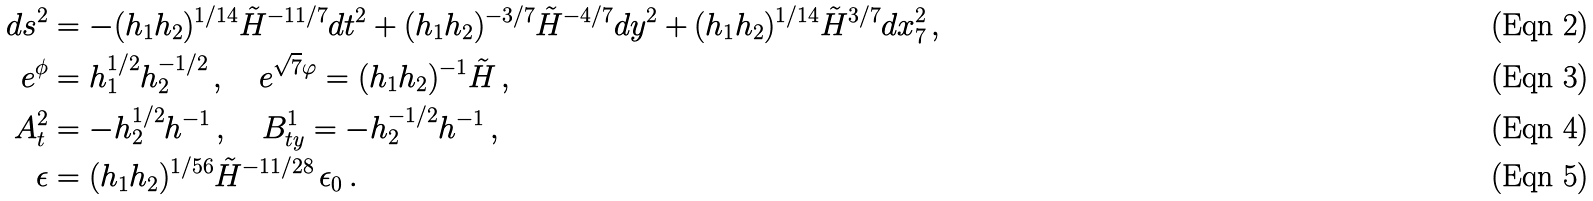<formula> <loc_0><loc_0><loc_500><loc_500>d s ^ { 2 } & = - ( h _ { 1 } h _ { 2 } ) ^ { 1 / 1 4 } \tilde { H } ^ { - 1 1 / 7 } d t ^ { 2 } + ( h _ { 1 } h _ { 2 } ) ^ { - 3 / 7 } \tilde { H } ^ { - 4 / 7 } d y ^ { 2 } + ( h _ { 1 } h _ { 2 } ) ^ { 1 / 1 4 } \tilde { H } ^ { 3 / 7 } d x _ { 7 } ^ { 2 } \, , \\ e ^ { \phi } & = h _ { 1 } ^ { 1 / 2 } h _ { 2 } ^ { - 1 / 2 } \, , \quad e ^ { \sqrt { 7 } \varphi } = ( h _ { 1 } h _ { 2 } ) ^ { - 1 } \tilde { H } \, , \\ A ^ { 2 } _ { t } & = - h _ { 2 } ^ { 1 / 2 } h ^ { - 1 } \, , \quad B ^ { 1 } _ { t y } = - h _ { 2 } ^ { - 1 / 2 } h ^ { - 1 } \, , \\ \epsilon & = ( h _ { 1 } h _ { 2 } ) ^ { 1 / 5 6 } \tilde { H } ^ { - 1 1 / 2 8 } \, \epsilon _ { 0 } \, .</formula> 